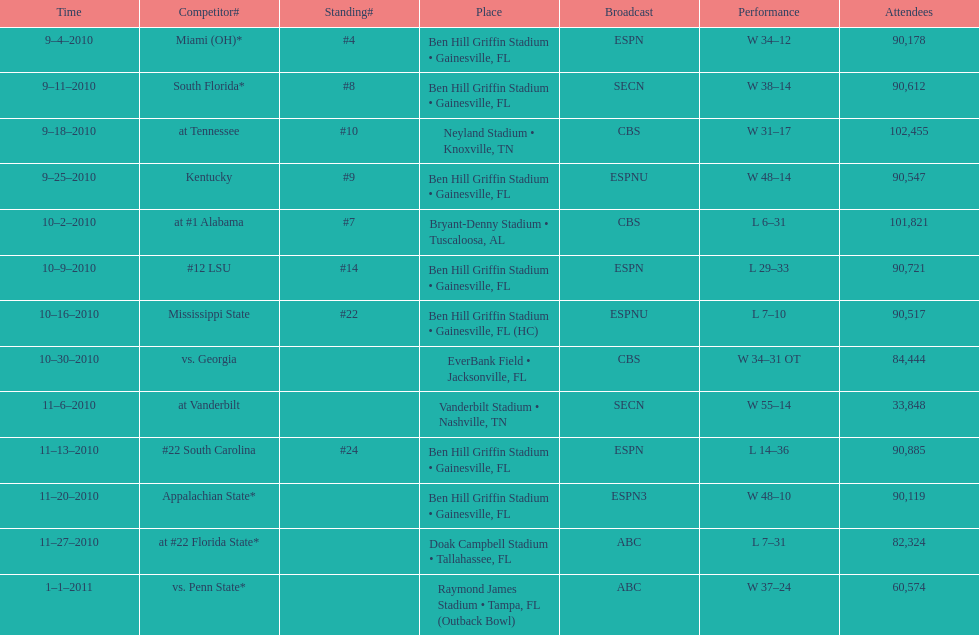The gators won the game on september 25, 2010. who won the previous game? Gators. 